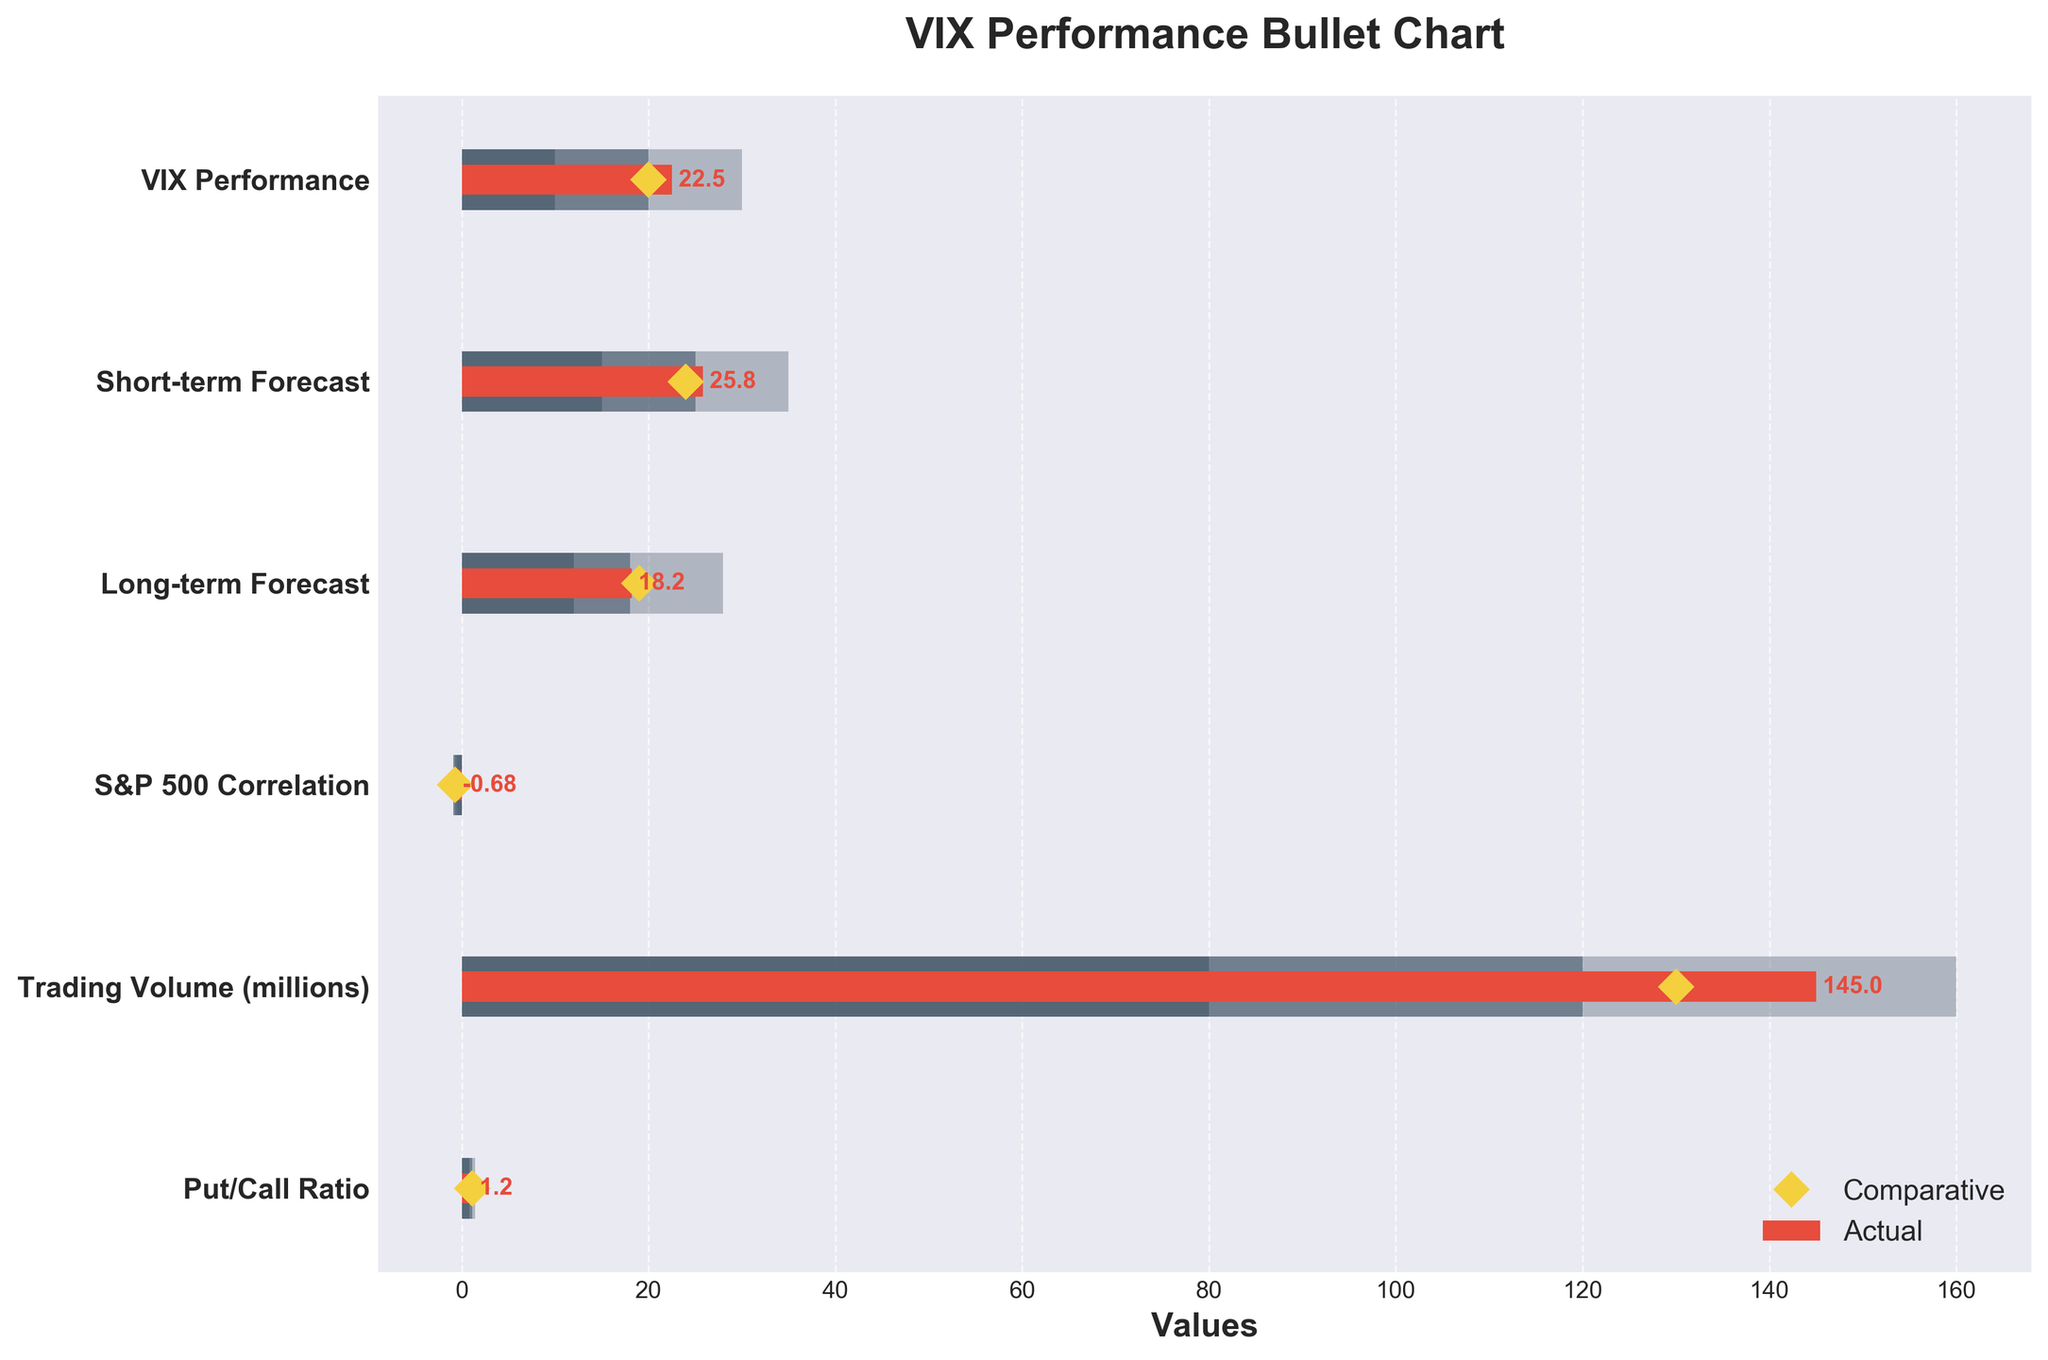What is the title of the chart? The chart's title can be found at the top, and it reads "VIX Performance Bullet Chart".
Answer: VIX Performance Bullet Chart What are the comparative values for the S&P 500 Correlation? The yellow diamond markers represent the comparative values; for the S&P 500 Correlation, the comparative value is shown aligned as -0.7.
Answer: -0.7 How does the Actual value of Trading Volume compare to its high range threshold? The Actual value for Trading Volume is 145, while the high range threshold for Trading Volume is 160.
Answer: It is below the threshold Which parameter has the highest Actual value? By looking at the red bars representing Actual values, Trading Volume has the highest value at 145 million.
Answer: Trading Volume What's the difference between the Actual and Comparative values for the Short-term Forecast? The Actual value for the Short-term Forecast is 25.8, and the Comparative value is 24. To find the difference: \(25.8 - 24 = 1.8\).
Answer: 1.8 Is the Actual value for the Put/Call Ratio within its medium range? The Actual value for the Put/Call ratio is 1.2. The medium range is indicated as between 1.1 and 1.4, so 1.2 falls within this range.
Answer: Yes Compare the Actual values of VIX Performance and Long-term Forecast; which is higher? The Actual value for VIX Performance is 22.5, and for Long-term Forecast, it is 18.2.
Answer: VIX Performance Which parameter has an Actual value that lies outside its defined ranges? All Actual values should be checked against their low, medium, and high ranges. The Actual value of 25.8 for Short-term Forecast is higher than the high range of 25.
Answer: Short-term Forecast By how much does the Trading Volume's Actual value exceed its Comparative value? The Actual value for Trading Volume is 145, and the Comparative value is 130. The difference is \(145 - 130 = 15\).
Answer: 15 